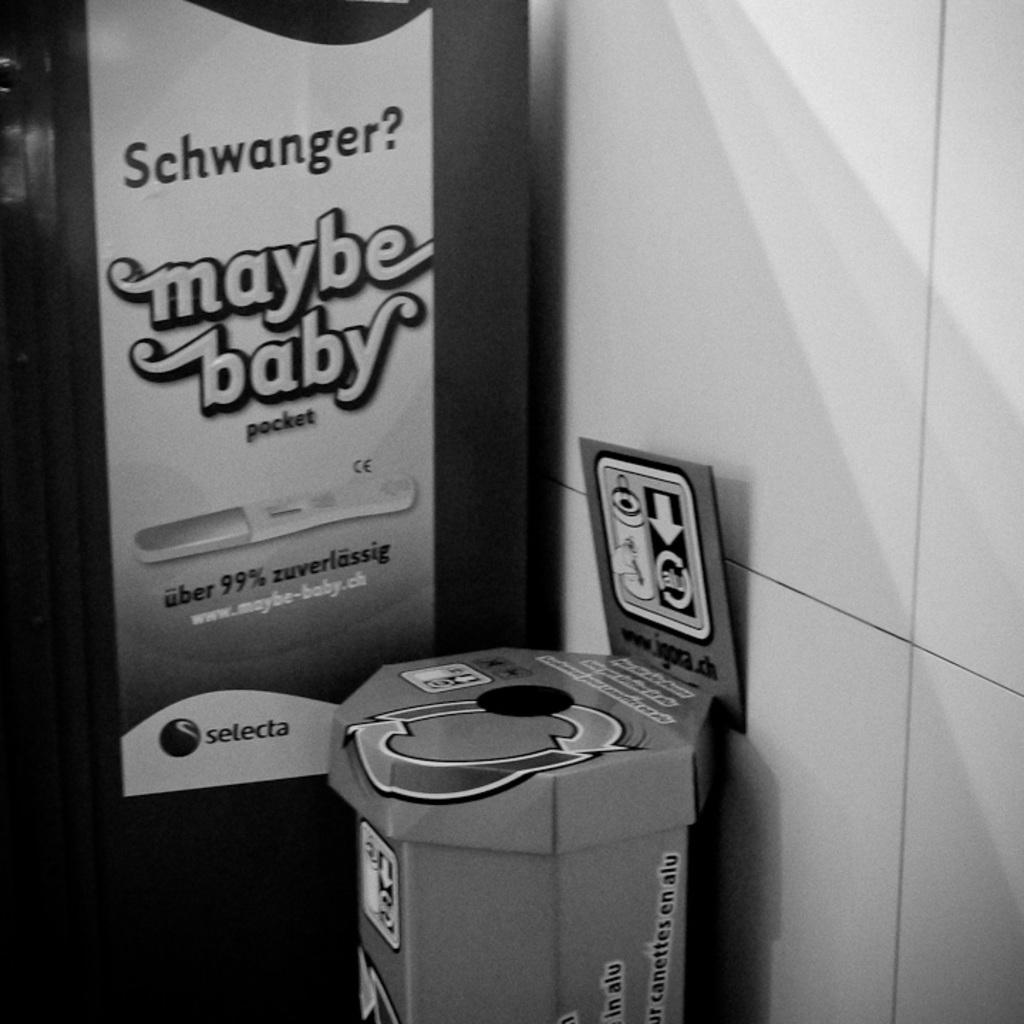What website is on the sign?
Your answer should be very brief. Www.maybe-baby.ch. What quote is being said on the sign on the wall?
Give a very brief answer. Maybe baby. 